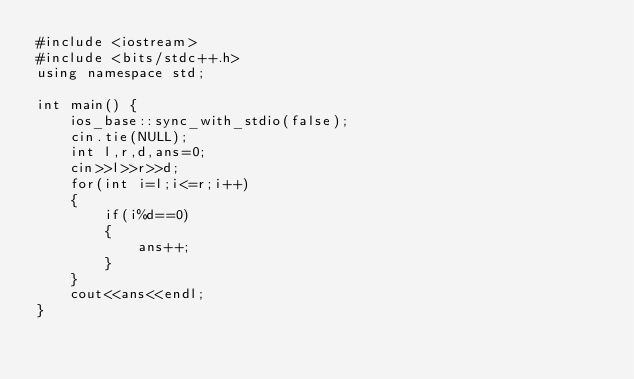Convert code to text. <code><loc_0><loc_0><loc_500><loc_500><_C++_>#include <iostream>
#include <bits/stdc++.h>
using namespace std;

int main() {
    ios_base::sync_with_stdio(false);
    cin.tie(NULL);
    int l,r,d,ans=0;
    cin>>l>>r>>d;
    for(int i=l;i<=r;i++)
    {
        if(i%d==0)
        {
            ans++;
        }
    }
    cout<<ans<<endl;
}
</code> 